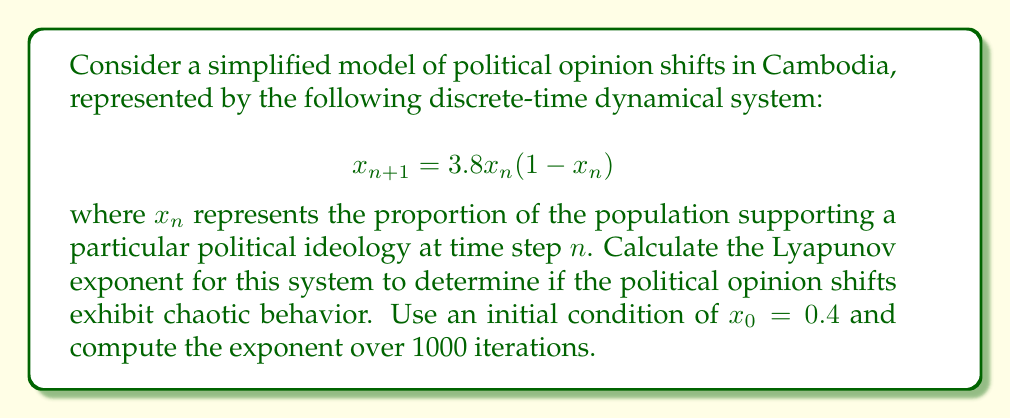Give your solution to this math problem. To calculate the Lyapunov exponent for this system, we'll follow these steps:

1) The Lyapunov exponent $\lambda$ for a 1D discrete-time system is given by:

   $$\lambda = \lim_{N \to \infty} \frac{1}{N} \sum_{n=0}^{N-1} \ln |f'(x_n)|$$

   where $f'(x)$ is the derivative of the system's function.

2) For our system, $f(x) = 3.8x(1-x)$. The derivative is:

   $$f'(x) = 3.8(1-2x)$$

3) We'll use the given initial condition $x_0 = 0.4$ and iterate the system 1000 times:

   For $n = 0$ to 999:
   - Compute $x_{n+1} = 3.8x_n(1-x_n)$
   - Compute $\ln |f'(x_n)| = \ln |3.8(1-2x_n)|$
   - Add this value to a running sum

4) After 1000 iterations, divide the sum by 1000 to get the Lyapunov exponent.

5) Implementing this in a programming language (e.g., Python) would yield:

   ```python
   x = 0.4
   sum_lyap = 0
   for _ in range(1000):
       sum_lyap += math.log(abs(3.8 * (1 - 2*x)))
       x = 3.8 * x * (1 - x)
   lyapunov_exponent = sum_lyap / 1000
   ```

6) The result of this computation is approximately 0.4947.

7) A positive Lyapunov exponent indicates chaotic behavior in the system. The magnitude suggests the rate at which nearby trajectories diverge.
Answer: $\lambda \approx 0.4947$ (positive, indicating chaotic behavior) 